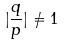<formula> <loc_0><loc_0><loc_500><loc_500>| \frac { q } { p } | \ne 1</formula> 